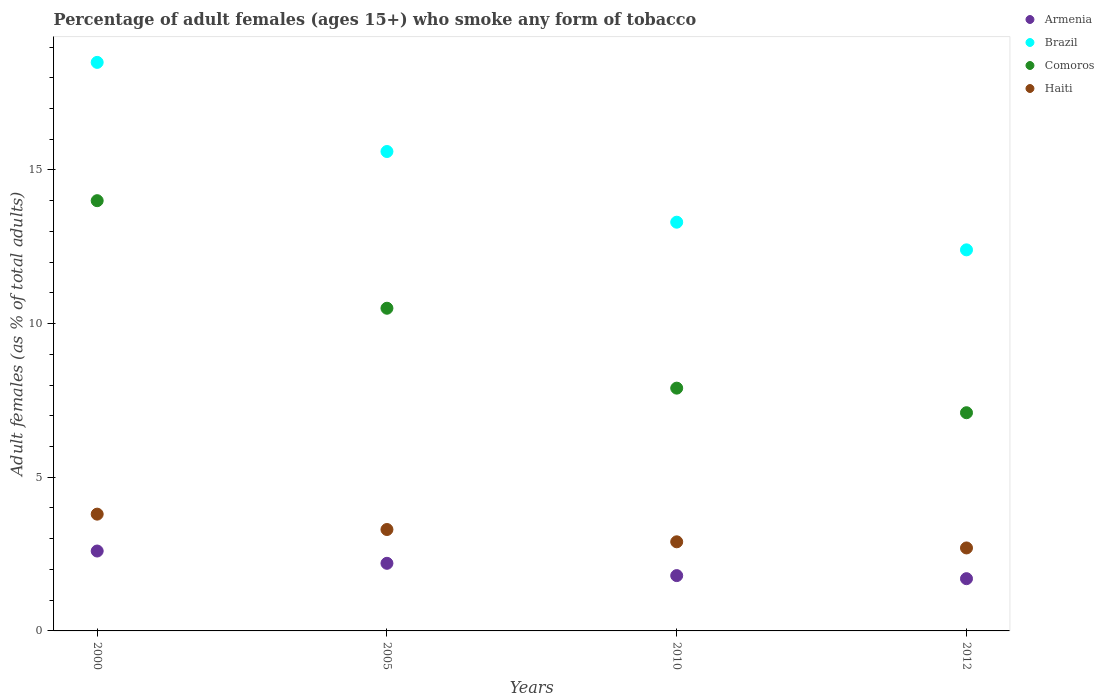In which year was the percentage of adult females who smoke in Haiti minimum?
Offer a terse response. 2012. What is the total percentage of adult females who smoke in Comoros in the graph?
Your response must be concise. 39.5. What is the average percentage of adult females who smoke in Brazil per year?
Your answer should be compact. 14.95. In how many years, is the percentage of adult females who smoke in Brazil greater than 9 %?
Your response must be concise. 4. What is the ratio of the percentage of adult females who smoke in Armenia in 2005 to that in 2010?
Provide a short and direct response. 1.22. Is the percentage of adult females who smoke in Comoros in 2005 less than that in 2010?
Ensure brevity in your answer.  No. What is the difference between the highest and the second highest percentage of adult females who smoke in Comoros?
Ensure brevity in your answer.  3.5. What is the difference between the highest and the lowest percentage of adult females who smoke in Brazil?
Offer a terse response. 6.1. Is the sum of the percentage of adult females who smoke in Armenia in 2000 and 2010 greater than the maximum percentage of adult females who smoke in Brazil across all years?
Your answer should be compact. No. Is it the case that in every year, the sum of the percentage of adult females who smoke in Comoros and percentage of adult females who smoke in Brazil  is greater than the sum of percentage of adult females who smoke in Armenia and percentage of adult females who smoke in Haiti?
Offer a terse response. Yes. Is the percentage of adult females who smoke in Comoros strictly less than the percentage of adult females who smoke in Haiti over the years?
Provide a short and direct response. No. How many dotlines are there?
Offer a terse response. 4. How many years are there in the graph?
Make the answer very short. 4. What is the difference between two consecutive major ticks on the Y-axis?
Provide a succinct answer. 5. What is the title of the graph?
Provide a short and direct response. Percentage of adult females (ages 15+) who smoke any form of tobacco. What is the label or title of the X-axis?
Your answer should be very brief. Years. What is the label or title of the Y-axis?
Offer a very short reply. Adult females (as % of total adults). What is the Adult females (as % of total adults) of Armenia in 2000?
Ensure brevity in your answer.  2.6. What is the Adult females (as % of total adults) in Brazil in 2000?
Keep it short and to the point. 18.5. What is the Adult females (as % of total adults) of Comoros in 2000?
Offer a terse response. 14. What is the Adult females (as % of total adults) of Haiti in 2000?
Your answer should be very brief. 3.8. What is the Adult females (as % of total adults) of Brazil in 2005?
Your response must be concise. 15.6. What is the Adult females (as % of total adults) of Comoros in 2010?
Your response must be concise. 7.9. What is the Adult females (as % of total adults) in Haiti in 2010?
Your answer should be very brief. 2.9. What is the Adult females (as % of total adults) of Brazil in 2012?
Offer a terse response. 12.4. What is the Adult females (as % of total adults) in Comoros in 2012?
Offer a terse response. 7.1. Across all years, what is the maximum Adult females (as % of total adults) of Brazil?
Keep it short and to the point. 18.5. Across all years, what is the maximum Adult females (as % of total adults) in Haiti?
Offer a terse response. 3.8. Across all years, what is the minimum Adult females (as % of total adults) of Comoros?
Provide a short and direct response. 7.1. What is the total Adult females (as % of total adults) in Armenia in the graph?
Make the answer very short. 8.3. What is the total Adult females (as % of total adults) in Brazil in the graph?
Provide a succinct answer. 59.8. What is the total Adult females (as % of total adults) of Comoros in the graph?
Make the answer very short. 39.5. What is the difference between the Adult females (as % of total adults) in Armenia in 2000 and that in 2005?
Your response must be concise. 0.4. What is the difference between the Adult females (as % of total adults) of Brazil in 2000 and that in 2010?
Your answer should be very brief. 5.2. What is the difference between the Adult females (as % of total adults) of Comoros in 2000 and that in 2010?
Make the answer very short. 6.1. What is the difference between the Adult females (as % of total adults) of Haiti in 2000 and that in 2010?
Offer a very short reply. 0.9. What is the difference between the Adult females (as % of total adults) in Comoros in 2000 and that in 2012?
Offer a very short reply. 6.9. What is the difference between the Adult females (as % of total adults) in Haiti in 2000 and that in 2012?
Provide a short and direct response. 1.1. What is the difference between the Adult females (as % of total adults) in Comoros in 2005 and that in 2010?
Your answer should be very brief. 2.6. What is the difference between the Adult females (as % of total adults) of Haiti in 2005 and that in 2010?
Provide a succinct answer. 0.4. What is the difference between the Adult females (as % of total adults) in Armenia in 2005 and that in 2012?
Your answer should be very brief. 0.5. What is the difference between the Adult females (as % of total adults) in Comoros in 2005 and that in 2012?
Provide a short and direct response. 3.4. What is the difference between the Adult females (as % of total adults) of Haiti in 2005 and that in 2012?
Make the answer very short. 0.6. What is the difference between the Adult females (as % of total adults) of Armenia in 2000 and the Adult females (as % of total adults) of Brazil in 2005?
Offer a terse response. -13. What is the difference between the Adult females (as % of total adults) of Armenia in 2000 and the Adult females (as % of total adults) of Comoros in 2005?
Your answer should be very brief. -7.9. What is the difference between the Adult females (as % of total adults) in Armenia in 2000 and the Adult females (as % of total adults) in Haiti in 2005?
Provide a short and direct response. -0.7. What is the difference between the Adult females (as % of total adults) of Brazil in 2000 and the Adult females (as % of total adults) of Comoros in 2005?
Offer a very short reply. 8. What is the difference between the Adult females (as % of total adults) of Armenia in 2000 and the Adult females (as % of total adults) of Brazil in 2010?
Your answer should be compact. -10.7. What is the difference between the Adult females (as % of total adults) of Armenia in 2000 and the Adult females (as % of total adults) of Comoros in 2010?
Keep it short and to the point. -5.3. What is the difference between the Adult females (as % of total adults) of Brazil in 2000 and the Adult females (as % of total adults) of Comoros in 2010?
Offer a terse response. 10.6. What is the difference between the Adult females (as % of total adults) in Comoros in 2000 and the Adult females (as % of total adults) in Haiti in 2010?
Offer a terse response. 11.1. What is the difference between the Adult females (as % of total adults) of Armenia in 2000 and the Adult females (as % of total adults) of Comoros in 2012?
Make the answer very short. -4.5. What is the difference between the Adult females (as % of total adults) of Armenia in 2000 and the Adult females (as % of total adults) of Haiti in 2012?
Give a very brief answer. -0.1. What is the difference between the Adult females (as % of total adults) in Brazil in 2000 and the Adult females (as % of total adults) in Comoros in 2012?
Provide a short and direct response. 11.4. What is the difference between the Adult females (as % of total adults) in Comoros in 2000 and the Adult females (as % of total adults) in Haiti in 2012?
Ensure brevity in your answer.  11.3. What is the difference between the Adult females (as % of total adults) of Armenia in 2005 and the Adult females (as % of total adults) of Comoros in 2010?
Provide a short and direct response. -5.7. What is the difference between the Adult females (as % of total adults) in Armenia in 2005 and the Adult females (as % of total adults) in Haiti in 2010?
Your answer should be compact. -0.7. What is the difference between the Adult females (as % of total adults) of Armenia in 2005 and the Adult females (as % of total adults) of Brazil in 2012?
Your response must be concise. -10.2. What is the difference between the Adult females (as % of total adults) of Armenia in 2005 and the Adult females (as % of total adults) of Comoros in 2012?
Offer a very short reply. -4.9. What is the difference between the Adult females (as % of total adults) in Brazil in 2005 and the Adult females (as % of total adults) in Haiti in 2012?
Your answer should be compact. 12.9. What is the difference between the Adult females (as % of total adults) of Armenia in 2010 and the Adult females (as % of total adults) of Brazil in 2012?
Ensure brevity in your answer.  -10.6. What is the difference between the Adult females (as % of total adults) in Armenia in 2010 and the Adult females (as % of total adults) in Haiti in 2012?
Provide a short and direct response. -0.9. What is the difference between the Adult females (as % of total adults) of Brazil in 2010 and the Adult females (as % of total adults) of Haiti in 2012?
Give a very brief answer. 10.6. What is the difference between the Adult females (as % of total adults) in Comoros in 2010 and the Adult females (as % of total adults) in Haiti in 2012?
Ensure brevity in your answer.  5.2. What is the average Adult females (as % of total adults) of Armenia per year?
Provide a succinct answer. 2.08. What is the average Adult females (as % of total adults) of Brazil per year?
Offer a terse response. 14.95. What is the average Adult females (as % of total adults) of Comoros per year?
Keep it short and to the point. 9.88. What is the average Adult females (as % of total adults) of Haiti per year?
Your response must be concise. 3.17. In the year 2000, what is the difference between the Adult females (as % of total adults) of Armenia and Adult females (as % of total adults) of Brazil?
Your answer should be very brief. -15.9. In the year 2005, what is the difference between the Adult females (as % of total adults) of Armenia and Adult females (as % of total adults) of Brazil?
Offer a very short reply. -13.4. In the year 2005, what is the difference between the Adult females (as % of total adults) of Armenia and Adult females (as % of total adults) of Haiti?
Ensure brevity in your answer.  -1.1. In the year 2005, what is the difference between the Adult females (as % of total adults) in Brazil and Adult females (as % of total adults) in Comoros?
Your answer should be very brief. 5.1. In the year 2005, what is the difference between the Adult females (as % of total adults) in Comoros and Adult females (as % of total adults) in Haiti?
Offer a very short reply. 7.2. In the year 2010, what is the difference between the Adult females (as % of total adults) of Armenia and Adult females (as % of total adults) of Brazil?
Make the answer very short. -11.5. In the year 2010, what is the difference between the Adult females (as % of total adults) of Armenia and Adult females (as % of total adults) of Comoros?
Your answer should be compact. -6.1. In the year 2010, what is the difference between the Adult females (as % of total adults) of Brazil and Adult females (as % of total adults) of Haiti?
Keep it short and to the point. 10.4. In the year 2012, what is the difference between the Adult females (as % of total adults) of Armenia and Adult females (as % of total adults) of Comoros?
Your answer should be compact. -5.4. In the year 2012, what is the difference between the Adult females (as % of total adults) of Armenia and Adult females (as % of total adults) of Haiti?
Provide a succinct answer. -1. In the year 2012, what is the difference between the Adult females (as % of total adults) in Comoros and Adult females (as % of total adults) in Haiti?
Make the answer very short. 4.4. What is the ratio of the Adult females (as % of total adults) in Armenia in 2000 to that in 2005?
Your response must be concise. 1.18. What is the ratio of the Adult females (as % of total adults) of Brazil in 2000 to that in 2005?
Give a very brief answer. 1.19. What is the ratio of the Adult females (as % of total adults) of Haiti in 2000 to that in 2005?
Provide a short and direct response. 1.15. What is the ratio of the Adult females (as % of total adults) of Armenia in 2000 to that in 2010?
Make the answer very short. 1.44. What is the ratio of the Adult females (as % of total adults) in Brazil in 2000 to that in 2010?
Ensure brevity in your answer.  1.39. What is the ratio of the Adult females (as % of total adults) in Comoros in 2000 to that in 2010?
Ensure brevity in your answer.  1.77. What is the ratio of the Adult females (as % of total adults) in Haiti in 2000 to that in 2010?
Keep it short and to the point. 1.31. What is the ratio of the Adult females (as % of total adults) in Armenia in 2000 to that in 2012?
Give a very brief answer. 1.53. What is the ratio of the Adult females (as % of total adults) in Brazil in 2000 to that in 2012?
Offer a very short reply. 1.49. What is the ratio of the Adult females (as % of total adults) of Comoros in 2000 to that in 2012?
Offer a terse response. 1.97. What is the ratio of the Adult females (as % of total adults) in Haiti in 2000 to that in 2012?
Provide a succinct answer. 1.41. What is the ratio of the Adult females (as % of total adults) in Armenia in 2005 to that in 2010?
Keep it short and to the point. 1.22. What is the ratio of the Adult females (as % of total adults) of Brazil in 2005 to that in 2010?
Offer a very short reply. 1.17. What is the ratio of the Adult females (as % of total adults) in Comoros in 2005 to that in 2010?
Make the answer very short. 1.33. What is the ratio of the Adult females (as % of total adults) in Haiti in 2005 to that in 2010?
Ensure brevity in your answer.  1.14. What is the ratio of the Adult females (as % of total adults) in Armenia in 2005 to that in 2012?
Offer a terse response. 1.29. What is the ratio of the Adult females (as % of total adults) of Brazil in 2005 to that in 2012?
Your answer should be compact. 1.26. What is the ratio of the Adult females (as % of total adults) in Comoros in 2005 to that in 2012?
Your answer should be compact. 1.48. What is the ratio of the Adult females (as % of total adults) in Haiti in 2005 to that in 2012?
Make the answer very short. 1.22. What is the ratio of the Adult females (as % of total adults) in Armenia in 2010 to that in 2012?
Ensure brevity in your answer.  1.06. What is the ratio of the Adult females (as % of total adults) in Brazil in 2010 to that in 2012?
Provide a short and direct response. 1.07. What is the ratio of the Adult females (as % of total adults) in Comoros in 2010 to that in 2012?
Offer a very short reply. 1.11. What is the ratio of the Adult females (as % of total adults) of Haiti in 2010 to that in 2012?
Make the answer very short. 1.07. What is the difference between the highest and the second highest Adult females (as % of total adults) of Armenia?
Give a very brief answer. 0.4. What is the difference between the highest and the second highest Adult females (as % of total adults) in Brazil?
Your answer should be very brief. 2.9. What is the difference between the highest and the lowest Adult females (as % of total adults) of Haiti?
Offer a terse response. 1.1. 